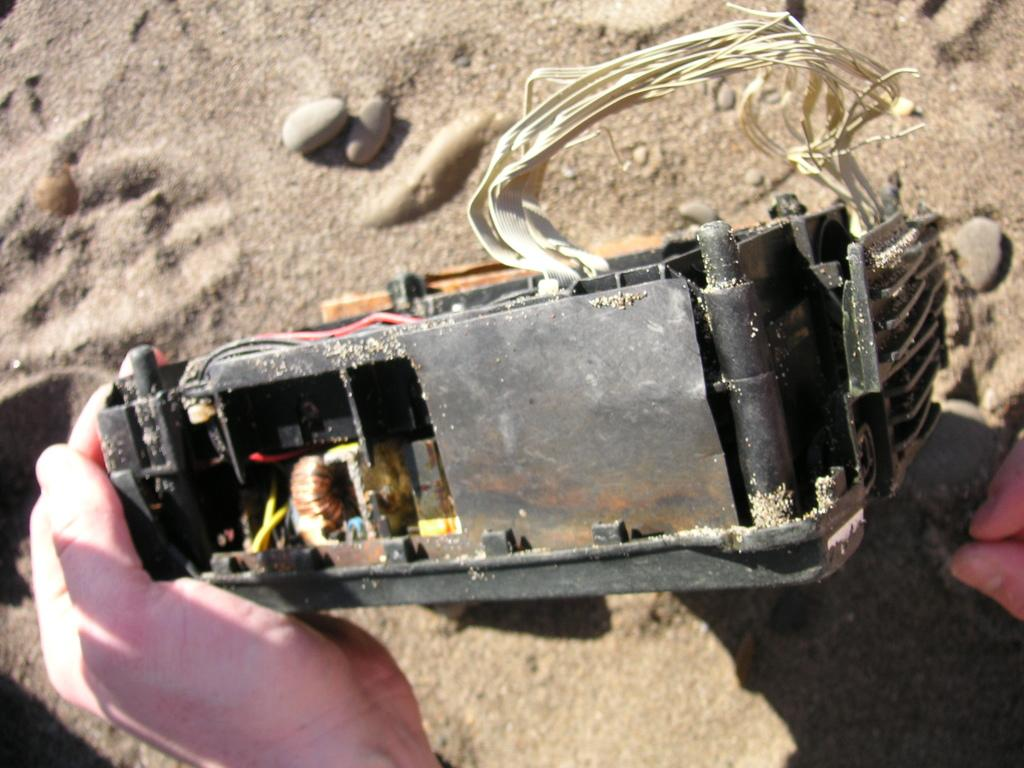What body part is visible in the image? There are hands of a person in the image. What object is present in the image besides the person's hands? There is a machine in the image. What type of natural elements can be seen in the background of the image? There are stones and sand in the background of the image. What type of muscle is being used to hold the loaf in the image? There is no loaf present in the image, so it is not possible to determine which muscle might be used to hold it. 